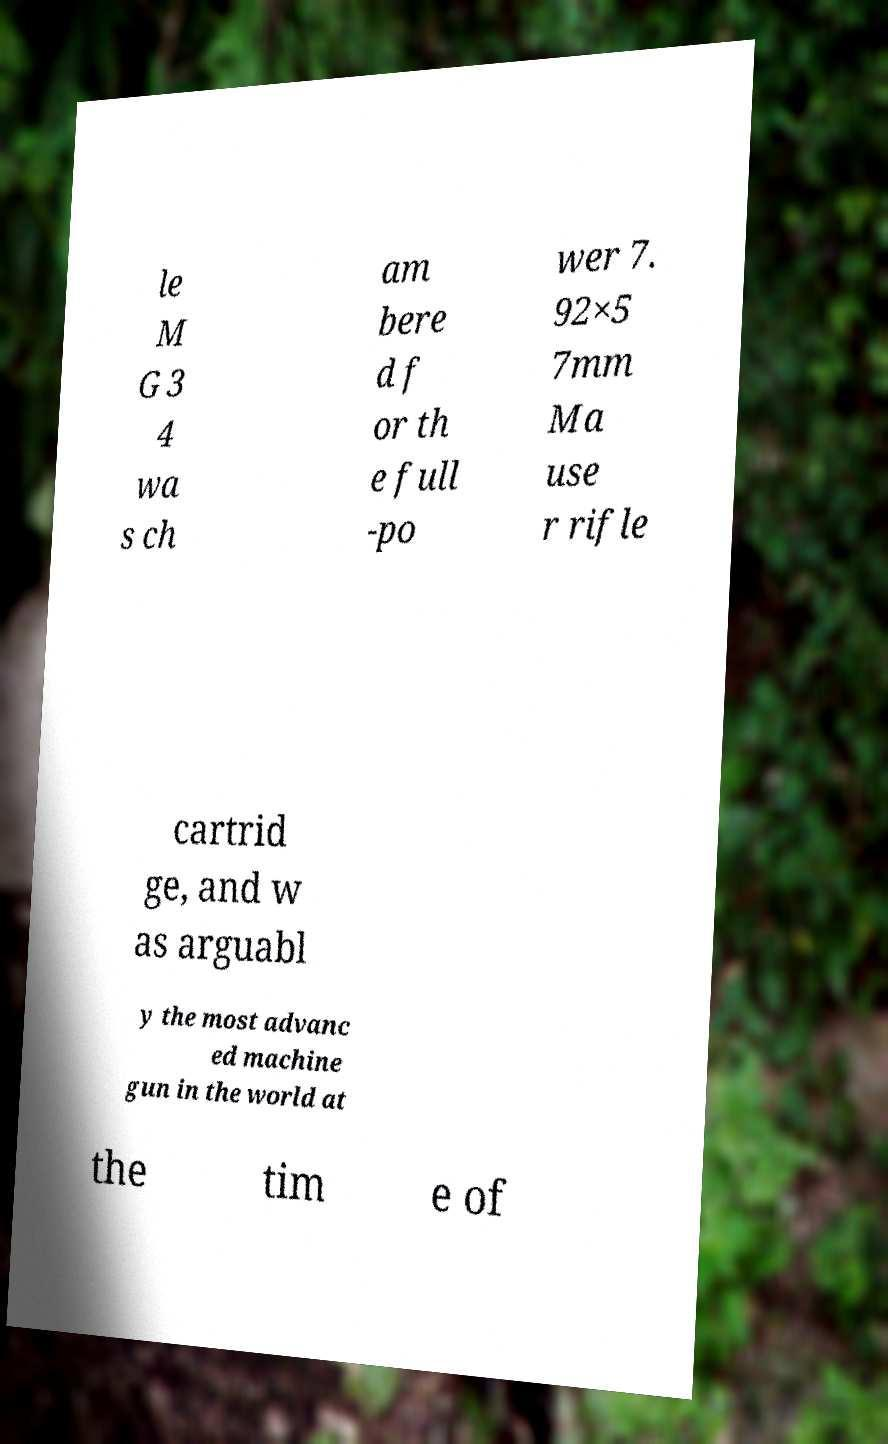Could you extract and type out the text from this image? le M G 3 4 wa s ch am bere d f or th e full -po wer 7. 92×5 7mm Ma use r rifle cartrid ge, and w as arguabl y the most advanc ed machine gun in the world at the tim e of 